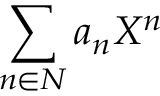Convert formula to latex. <formula><loc_0><loc_0><loc_500><loc_500>\sum _ { n \in N } a _ { n } X ^ { n }</formula> 